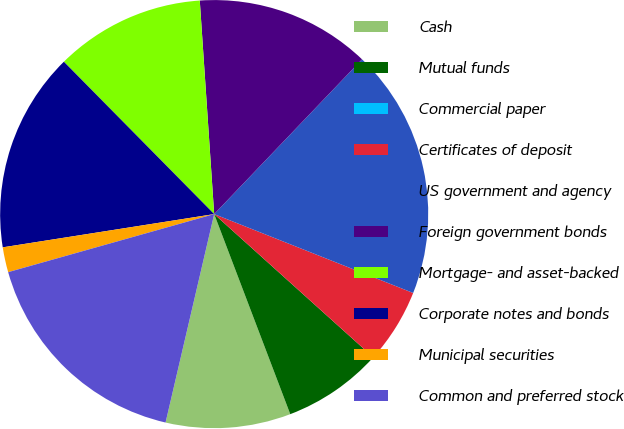Convert chart to OTSL. <chart><loc_0><loc_0><loc_500><loc_500><pie_chart><fcel>Cash<fcel>Mutual funds<fcel>Commercial paper<fcel>Certificates of deposit<fcel>US government and agency<fcel>Foreign government bonds<fcel>Mortgage- and asset-backed<fcel>Corporate notes and bonds<fcel>Municipal securities<fcel>Common and preferred stock<nl><fcel>9.43%<fcel>7.55%<fcel>0.0%<fcel>5.66%<fcel>18.87%<fcel>13.21%<fcel>11.32%<fcel>15.09%<fcel>1.89%<fcel>16.98%<nl></chart> 